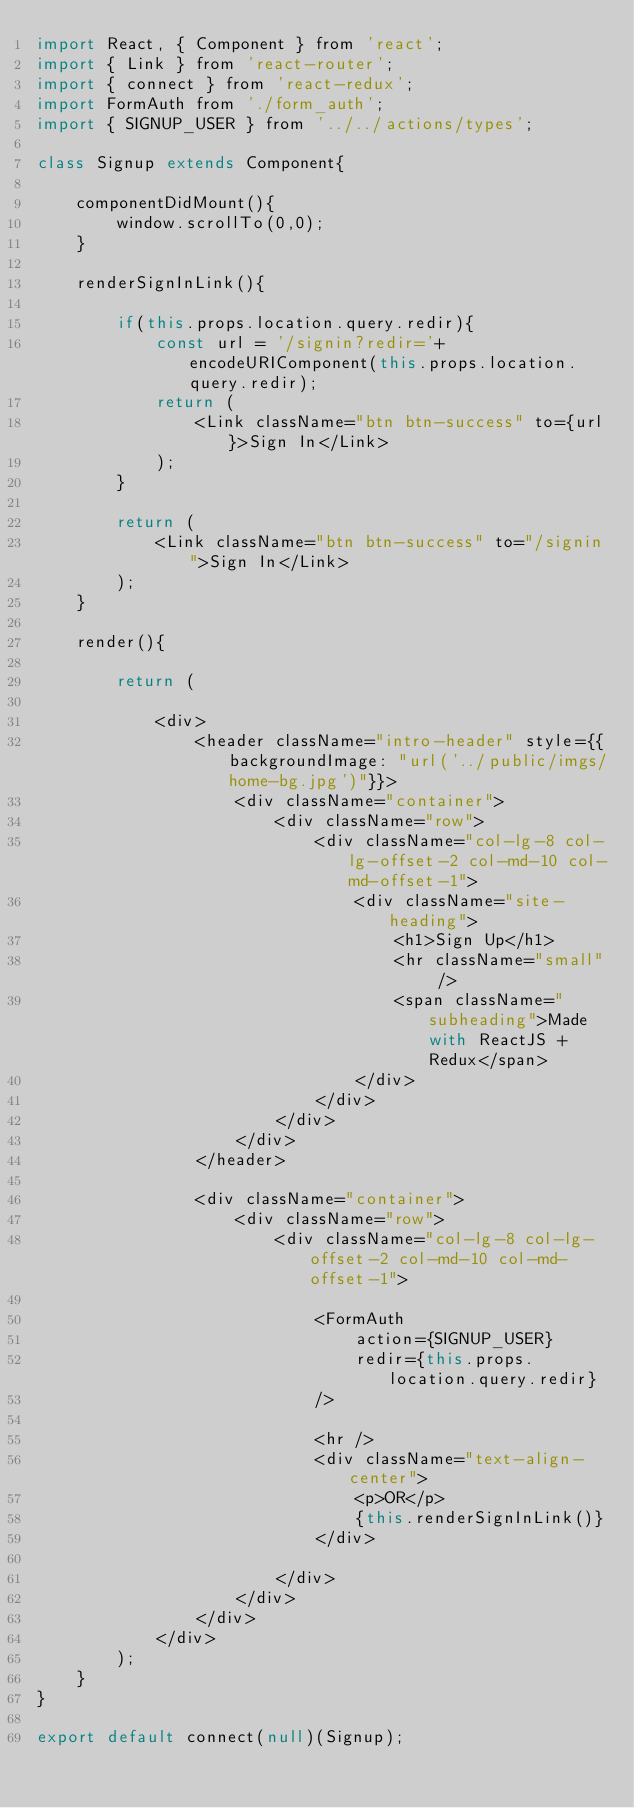Convert code to text. <code><loc_0><loc_0><loc_500><loc_500><_JavaScript_>import React, { Component } from 'react';
import { Link } from 'react-router';
import { connect } from 'react-redux';
import FormAuth from './form_auth';
import { SIGNUP_USER } from '../../actions/types';

class Signup extends Component{

    componentDidMount(){
        window.scrollTo(0,0);
    }

    renderSignInLink(){

        if(this.props.location.query.redir){
            const url = '/signin?redir='+encodeURIComponent(this.props.location.query.redir);
            return (
                <Link className="btn btn-success" to={url}>Sign In</Link>
            );
        }

        return (
            <Link className="btn btn-success" to="/signin">Sign In</Link>
        );
    }

    render(){

        return (

            <div>
                <header className="intro-header" style={{backgroundImage: "url('../public/imgs/home-bg.jpg')"}}>
                    <div className="container">
                        <div className="row">
                            <div className="col-lg-8 col-lg-offset-2 col-md-10 col-md-offset-1">
                                <div className="site-heading">
                                    <h1>Sign Up</h1>
                                    <hr className="small" />
                                    <span className="subheading">Made with ReactJS + Redux</span>
                                </div>
                            </div>
                        </div>
                    </div>
                </header>

                <div className="container">
                    <div className="row">
                        <div className="col-lg-8 col-lg-offset-2 col-md-10 col-md-offset-1">

                            <FormAuth 
                                action={SIGNUP_USER}
                                redir={this.props.location.query.redir}
                            />

                            <hr />
                            <div className="text-align-center">
                                <p>OR</p>
                                {this.renderSignInLink()}
                            </div>

                        </div>
                    </div>
                </div>
            </div> 
        );
    }
}

export default connect(null)(Signup);
</code> 